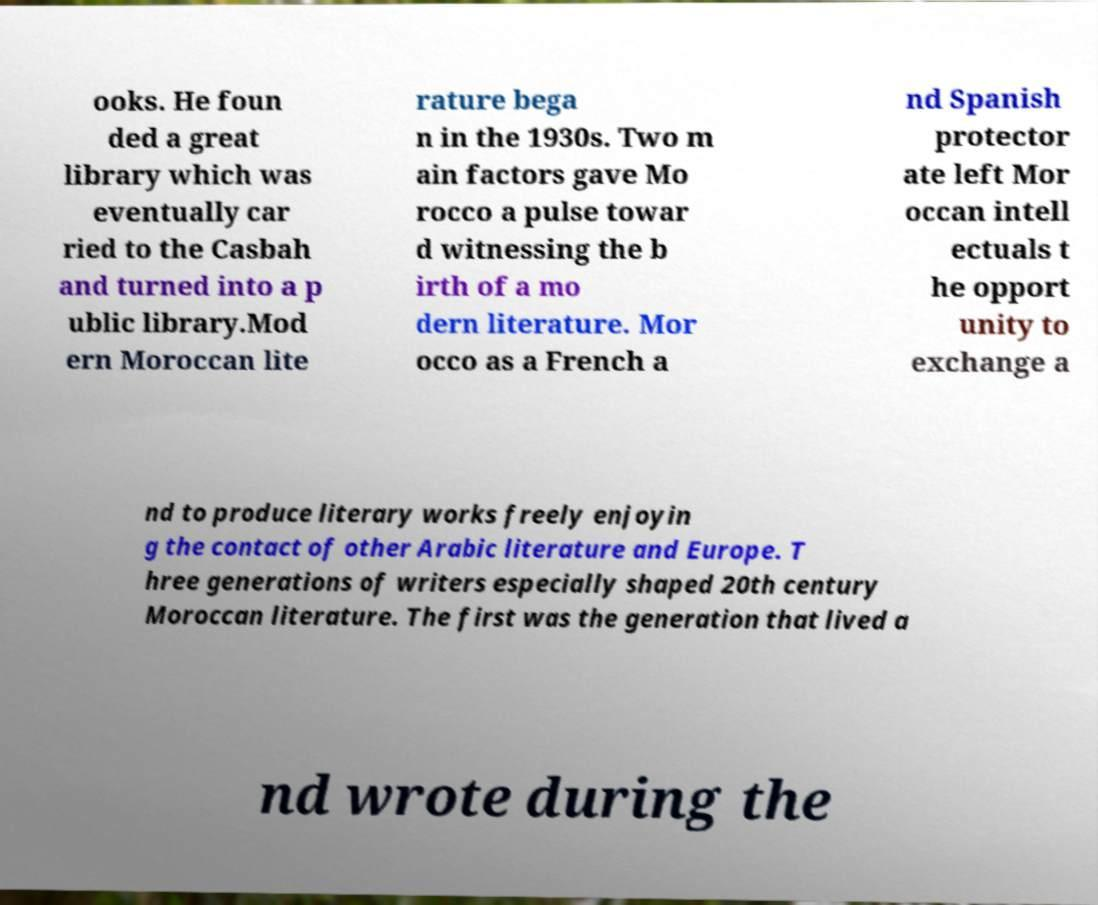Could you assist in decoding the text presented in this image and type it out clearly? ooks. He foun ded a great library which was eventually car ried to the Casbah and turned into a p ublic library.Mod ern Moroccan lite rature bega n in the 1930s. Two m ain factors gave Mo rocco a pulse towar d witnessing the b irth of a mo dern literature. Mor occo as a French a nd Spanish protector ate left Mor occan intell ectuals t he opport unity to exchange a nd to produce literary works freely enjoyin g the contact of other Arabic literature and Europe. T hree generations of writers especially shaped 20th century Moroccan literature. The first was the generation that lived a nd wrote during the 